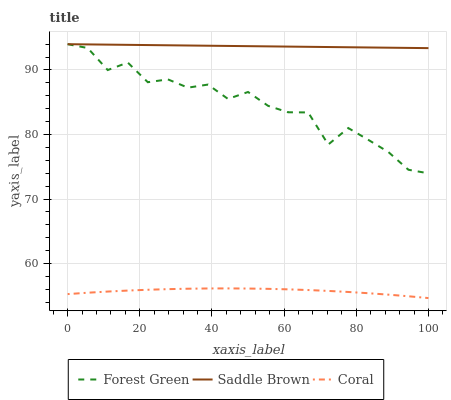Does Coral have the minimum area under the curve?
Answer yes or no. Yes. Does Saddle Brown have the maximum area under the curve?
Answer yes or no. Yes. Does Forest Green have the minimum area under the curve?
Answer yes or no. No. Does Forest Green have the maximum area under the curve?
Answer yes or no. No. Is Saddle Brown the smoothest?
Answer yes or no. Yes. Is Forest Green the roughest?
Answer yes or no. Yes. Is Forest Green the smoothest?
Answer yes or no. No. Is Saddle Brown the roughest?
Answer yes or no. No. Does Forest Green have the lowest value?
Answer yes or no. No. Does Saddle Brown have the highest value?
Answer yes or no. Yes. Is Coral less than Forest Green?
Answer yes or no. Yes. Is Forest Green greater than Coral?
Answer yes or no. Yes. Does Saddle Brown intersect Forest Green?
Answer yes or no. Yes. Is Saddle Brown less than Forest Green?
Answer yes or no. No. Is Saddle Brown greater than Forest Green?
Answer yes or no. No. Does Coral intersect Forest Green?
Answer yes or no. No. 